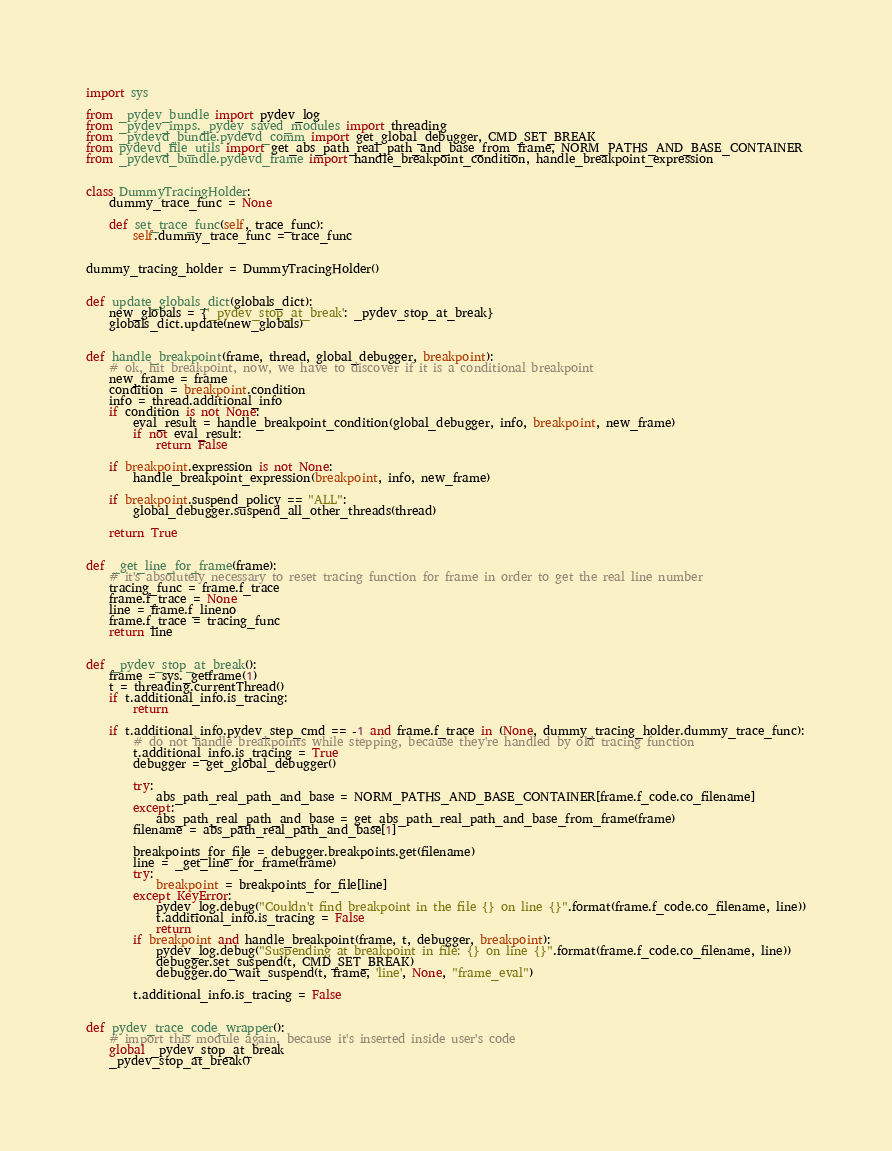Convert code to text. <code><loc_0><loc_0><loc_500><loc_500><_Python_>import sys

from _pydev_bundle import pydev_log
from _pydev_imps._pydev_saved_modules import threading
from _pydevd_bundle.pydevd_comm import get_global_debugger, CMD_SET_BREAK
from pydevd_file_utils import get_abs_path_real_path_and_base_from_frame, NORM_PATHS_AND_BASE_CONTAINER
from _pydevd_bundle.pydevd_frame import handle_breakpoint_condition, handle_breakpoint_expression


class DummyTracingHolder:
    dummy_trace_func = None

    def set_trace_func(self, trace_func):
        self.dummy_trace_func = trace_func


dummy_tracing_holder = DummyTracingHolder()


def update_globals_dict(globals_dict):
    new_globals = {'_pydev_stop_at_break': _pydev_stop_at_break}
    globals_dict.update(new_globals)


def handle_breakpoint(frame, thread, global_debugger, breakpoint):
    # ok, hit breakpoint, now, we have to discover if it is a conditional breakpoint
    new_frame = frame
    condition = breakpoint.condition
    info = thread.additional_info
    if condition is not None:
        eval_result = handle_breakpoint_condition(global_debugger, info, breakpoint, new_frame)
        if not eval_result:
            return False

    if breakpoint.expression is not None:
        handle_breakpoint_expression(breakpoint, info, new_frame)

    if breakpoint.suspend_policy == "ALL":
        global_debugger.suspend_all_other_threads(thread)

    return True


def _get_line_for_frame(frame):
    # it's absolutely necessary to reset tracing function for frame in order to get the real line number
    tracing_func = frame.f_trace
    frame.f_trace = None
    line = frame.f_lineno
    frame.f_trace = tracing_func
    return line


def _pydev_stop_at_break():
    frame = sys._getframe(1)
    t = threading.currentThread()
    if t.additional_info.is_tracing:
        return

    if t.additional_info.pydev_step_cmd == -1 and frame.f_trace in (None, dummy_tracing_holder.dummy_trace_func):
        # do not handle breakpoints while stepping, because they're handled by old tracing function
        t.additional_info.is_tracing = True
        debugger = get_global_debugger()

        try:
            abs_path_real_path_and_base = NORM_PATHS_AND_BASE_CONTAINER[frame.f_code.co_filename]
        except:
            abs_path_real_path_and_base = get_abs_path_real_path_and_base_from_frame(frame)
        filename = abs_path_real_path_and_base[1]

        breakpoints_for_file = debugger.breakpoints.get(filename)
        line = _get_line_for_frame(frame)
        try:
            breakpoint = breakpoints_for_file[line]
        except KeyError:
            pydev_log.debug("Couldn't find breakpoint in the file {} on line {}".format(frame.f_code.co_filename, line))
            t.additional_info.is_tracing = False
            return
        if breakpoint and handle_breakpoint(frame, t, debugger, breakpoint):
            pydev_log.debug("Suspending at breakpoint in file: {} on line {}".format(frame.f_code.co_filename, line))
            debugger.set_suspend(t, CMD_SET_BREAK)
            debugger.do_wait_suspend(t, frame, 'line', None, "frame_eval")

        t.additional_info.is_tracing = False


def pydev_trace_code_wrapper():
    # import this module again, because it's inserted inside user's code
    global _pydev_stop_at_break
    _pydev_stop_at_break()
</code> 